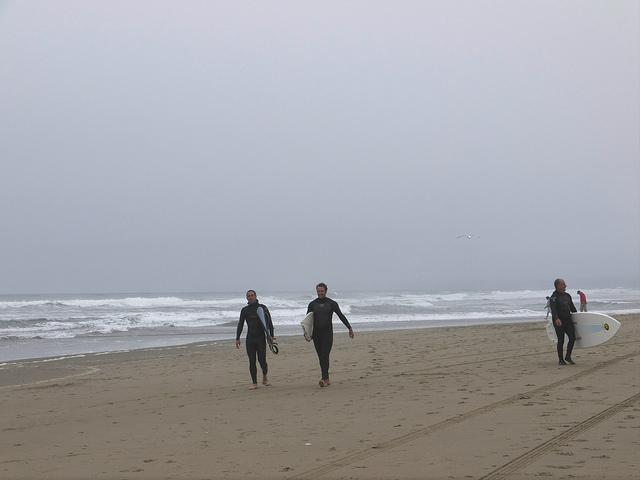The lines on the sand were made by what part of a vehicle? Please explain your reasoning. tires. Narrow, straight tracks can be seen in the sand, equal distance apart, denoting a vehicle track. 